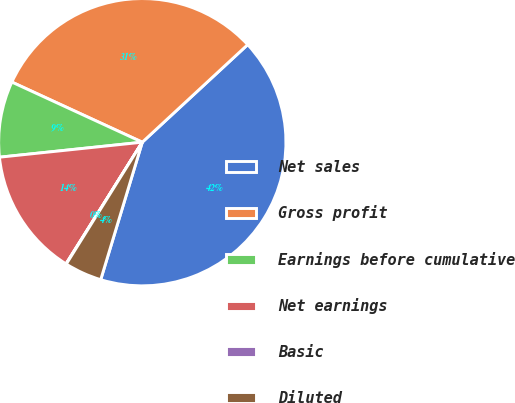Convert chart. <chart><loc_0><loc_0><loc_500><loc_500><pie_chart><fcel>Net sales<fcel>Gross profit<fcel>Earnings before cumulative<fcel>Net earnings<fcel>Basic<fcel>Diluted<nl><fcel>41.56%<fcel>31.24%<fcel>8.54%<fcel>14.42%<fcel>0.04%<fcel>4.2%<nl></chart> 